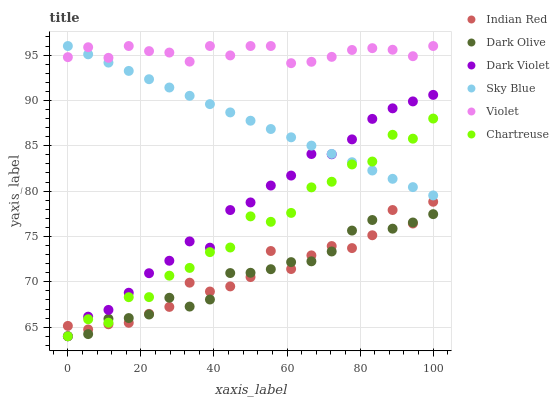Does Dark Olive have the minimum area under the curve?
Answer yes or no. Yes. Does Violet have the maximum area under the curve?
Answer yes or no. Yes. Does Dark Violet have the minimum area under the curve?
Answer yes or no. No. Does Dark Violet have the maximum area under the curve?
Answer yes or no. No. Is Sky Blue the smoothest?
Answer yes or no. Yes. Is Chartreuse the roughest?
Answer yes or no. Yes. Is Dark Violet the smoothest?
Answer yes or no. No. Is Dark Violet the roughest?
Answer yes or no. No. Does Dark Olive have the lowest value?
Answer yes or no. Yes. Does Indian Red have the lowest value?
Answer yes or no. No. Does Sky Blue have the highest value?
Answer yes or no. Yes. Does Dark Violet have the highest value?
Answer yes or no. No. Is Chartreuse less than Violet?
Answer yes or no. Yes. Is Violet greater than Indian Red?
Answer yes or no. Yes. Does Chartreuse intersect Dark Violet?
Answer yes or no. Yes. Is Chartreuse less than Dark Violet?
Answer yes or no. No. Is Chartreuse greater than Dark Violet?
Answer yes or no. No. Does Chartreuse intersect Violet?
Answer yes or no. No. 